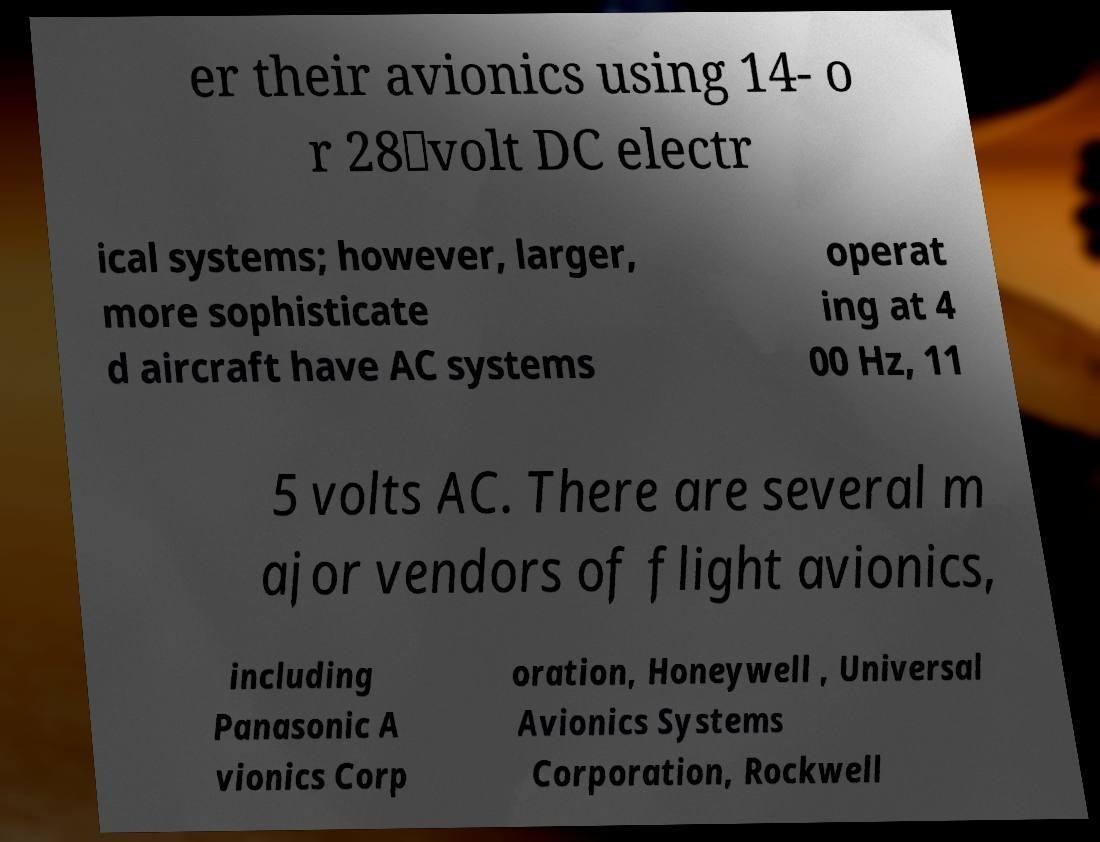Could you extract and type out the text from this image? er their avionics using 14- o r 28‑volt DC electr ical systems; however, larger, more sophisticate d aircraft have AC systems operat ing at 4 00 Hz, 11 5 volts AC. There are several m ajor vendors of flight avionics, including Panasonic A vionics Corp oration, Honeywell , Universal Avionics Systems Corporation, Rockwell 